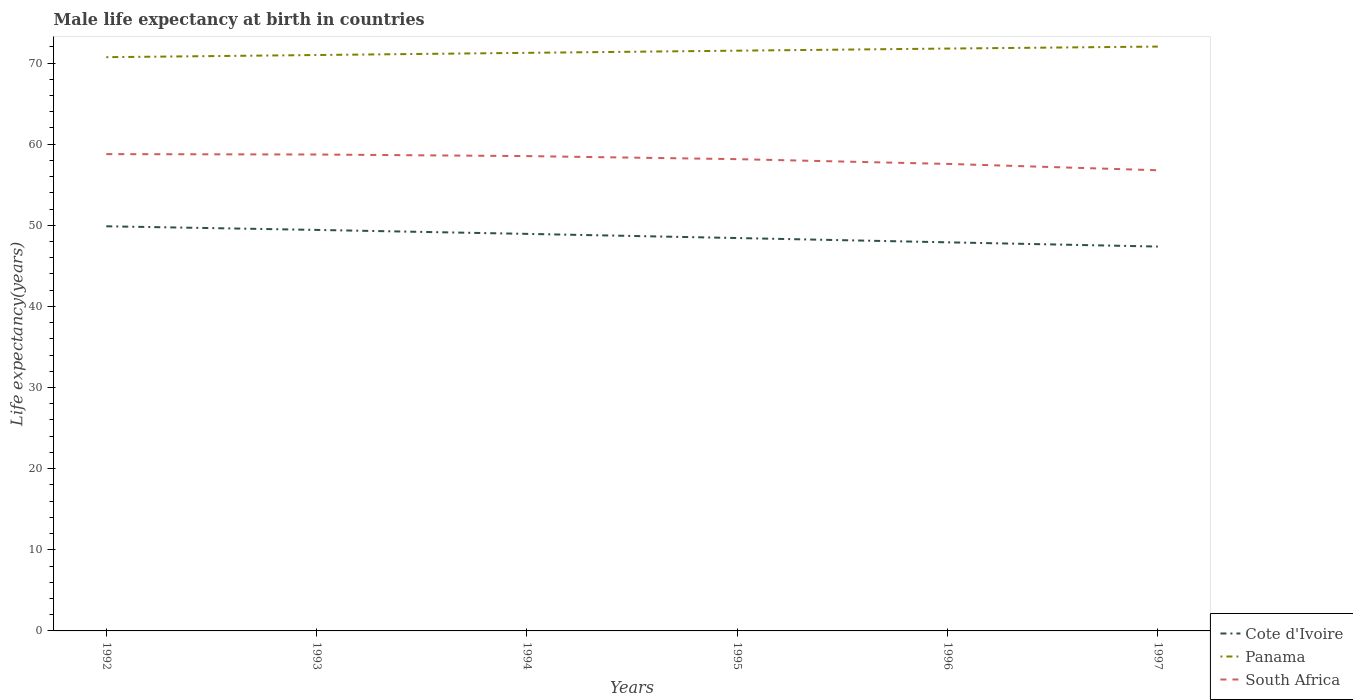Does the line corresponding to South Africa intersect with the line corresponding to Cote d'Ivoire?
Make the answer very short. No. Is the number of lines equal to the number of legend labels?
Keep it short and to the point. Yes. Across all years, what is the maximum male life expectancy at birth in Cote d'Ivoire?
Provide a succinct answer. 47.38. In which year was the male life expectancy at birth in Panama maximum?
Your answer should be very brief. 1992. What is the total male life expectancy at birth in Panama in the graph?
Provide a short and direct response. -0.25. What is the difference between the highest and the second highest male life expectancy at birth in Panama?
Your answer should be very brief. 1.31. What is the difference between the highest and the lowest male life expectancy at birth in Cote d'Ivoire?
Offer a very short reply. 3. How many lines are there?
Your answer should be compact. 3. Does the graph contain any zero values?
Provide a succinct answer. No. How many legend labels are there?
Provide a short and direct response. 3. What is the title of the graph?
Offer a very short reply. Male life expectancy at birth in countries. What is the label or title of the X-axis?
Provide a short and direct response. Years. What is the label or title of the Y-axis?
Offer a very short reply. Life expectancy(years). What is the Life expectancy(years) of Cote d'Ivoire in 1992?
Make the answer very short. 49.88. What is the Life expectancy(years) of Panama in 1992?
Make the answer very short. 70.72. What is the Life expectancy(years) of South Africa in 1992?
Your answer should be compact. 58.77. What is the Life expectancy(years) in Cote d'Ivoire in 1993?
Provide a succinct answer. 49.43. What is the Life expectancy(years) of Panama in 1993?
Make the answer very short. 70.99. What is the Life expectancy(years) of South Africa in 1993?
Provide a short and direct response. 58.72. What is the Life expectancy(years) in Cote d'Ivoire in 1994?
Provide a short and direct response. 48.94. What is the Life expectancy(years) of Panama in 1994?
Your answer should be very brief. 71.25. What is the Life expectancy(years) in South Africa in 1994?
Provide a short and direct response. 58.53. What is the Life expectancy(years) of Cote d'Ivoire in 1995?
Keep it short and to the point. 48.43. What is the Life expectancy(years) of Panama in 1995?
Your answer should be very brief. 71.52. What is the Life expectancy(years) in South Africa in 1995?
Provide a short and direct response. 58.15. What is the Life expectancy(years) in Cote d'Ivoire in 1996?
Your answer should be compact. 47.9. What is the Life expectancy(years) of Panama in 1996?
Your answer should be compact. 71.78. What is the Life expectancy(years) of South Africa in 1996?
Keep it short and to the point. 57.56. What is the Life expectancy(years) in Cote d'Ivoire in 1997?
Provide a succinct answer. 47.38. What is the Life expectancy(years) of Panama in 1997?
Provide a succinct answer. 72.03. What is the Life expectancy(years) of South Africa in 1997?
Your answer should be very brief. 56.78. Across all years, what is the maximum Life expectancy(years) of Cote d'Ivoire?
Offer a very short reply. 49.88. Across all years, what is the maximum Life expectancy(years) in Panama?
Offer a terse response. 72.03. Across all years, what is the maximum Life expectancy(years) in South Africa?
Give a very brief answer. 58.77. Across all years, what is the minimum Life expectancy(years) in Cote d'Ivoire?
Make the answer very short. 47.38. Across all years, what is the minimum Life expectancy(years) of Panama?
Offer a very short reply. 70.72. Across all years, what is the minimum Life expectancy(years) of South Africa?
Your response must be concise. 56.78. What is the total Life expectancy(years) of Cote d'Ivoire in the graph?
Keep it short and to the point. 291.95. What is the total Life expectancy(years) of Panama in the graph?
Your answer should be compact. 428.29. What is the total Life expectancy(years) of South Africa in the graph?
Your answer should be compact. 348.52. What is the difference between the Life expectancy(years) in Cote d'Ivoire in 1992 and that in 1993?
Offer a very short reply. 0.45. What is the difference between the Life expectancy(years) in Panama in 1992 and that in 1993?
Keep it short and to the point. -0.27. What is the difference between the Life expectancy(years) of South Africa in 1992 and that in 1993?
Offer a terse response. 0.05. What is the difference between the Life expectancy(years) of Cote d'Ivoire in 1992 and that in 1994?
Ensure brevity in your answer.  0.94. What is the difference between the Life expectancy(years) in Panama in 1992 and that in 1994?
Give a very brief answer. -0.54. What is the difference between the Life expectancy(years) in South Africa in 1992 and that in 1994?
Provide a succinct answer. 0.24. What is the difference between the Life expectancy(years) in Cote d'Ivoire in 1992 and that in 1995?
Your answer should be compact. 1.45. What is the difference between the Life expectancy(years) in Panama in 1992 and that in 1995?
Provide a succinct answer. -0.8. What is the difference between the Life expectancy(years) of South Africa in 1992 and that in 1995?
Keep it short and to the point. 0.62. What is the difference between the Life expectancy(years) in Cote d'Ivoire in 1992 and that in 1996?
Provide a succinct answer. 1.98. What is the difference between the Life expectancy(years) in Panama in 1992 and that in 1996?
Provide a short and direct response. -1.06. What is the difference between the Life expectancy(years) in South Africa in 1992 and that in 1996?
Keep it short and to the point. 1.21. What is the difference between the Life expectancy(years) in Cote d'Ivoire in 1992 and that in 1997?
Provide a succinct answer. 2.5. What is the difference between the Life expectancy(years) in Panama in 1992 and that in 1997?
Your answer should be very brief. -1.31. What is the difference between the Life expectancy(years) of South Africa in 1992 and that in 1997?
Provide a succinct answer. 1.99. What is the difference between the Life expectancy(years) in Cote d'Ivoire in 1993 and that in 1994?
Your answer should be compact. 0.49. What is the difference between the Life expectancy(years) of Panama in 1993 and that in 1994?
Make the answer very short. -0.27. What is the difference between the Life expectancy(years) of South Africa in 1993 and that in 1994?
Your answer should be very brief. 0.2. What is the difference between the Life expectancy(years) in Panama in 1993 and that in 1995?
Your answer should be very brief. -0.54. What is the difference between the Life expectancy(years) in South Africa in 1993 and that in 1995?
Offer a terse response. 0.57. What is the difference between the Life expectancy(years) in Cote d'Ivoire in 1993 and that in 1996?
Your response must be concise. 1.53. What is the difference between the Life expectancy(years) of Panama in 1993 and that in 1996?
Your answer should be compact. -0.8. What is the difference between the Life expectancy(years) in South Africa in 1993 and that in 1996?
Your answer should be compact. 1.16. What is the difference between the Life expectancy(years) in Cote d'Ivoire in 1993 and that in 1997?
Keep it short and to the point. 2.05. What is the difference between the Life expectancy(years) in Panama in 1993 and that in 1997?
Make the answer very short. -1.04. What is the difference between the Life expectancy(years) in South Africa in 1993 and that in 1997?
Provide a short and direct response. 1.94. What is the difference between the Life expectancy(years) in Cote d'Ivoire in 1994 and that in 1995?
Make the answer very short. 0.51. What is the difference between the Life expectancy(years) of Panama in 1994 and that in 1995?
Provide a succinct answer. -0.27. What is the difference between the Life expectancy(years) in South Africa in 1994 and that in 1995?
Offer a terse response. 0.38. What is the difference between the Life expectancy(years) of Cote d'Ivoire in 1994 and that in 1996?
Give a very brief answer. 1.04. What is the difference between the Life expectancy(years) of Panama in 1994 and that in 1996?
Your response must be concise. -0.53. What is the difference between the Life expectancy(years) in South Africa in 1994 and that in 1996?
Keep it short and to the point. 0.96. What is the difference between the Life expectancy(years) of Cote d'Ivoire in 1994 and that in 1997?
Keep it short and to the point. 1.56. What is the difference between the Life expectancy(years) in Panama in 1994 and that in 1997?
Ensure brevity in your answer.  -0.77. What is the difference between the Life expectancy(years) in South Africa in 1994 and that in 1997?
Your response must be concise. 1.75. What is the difference between the Life expectancy(years) in Cote d'Ivoire in 1995 and that in 1996?
Ensure brevity in your answer.  0.53. What is the difference between the Life expectancy(years) of Panama in 1995 and that in 1996?
Your answer should be compact. -0.26. What is the difference between the Life expectancy(years) of South Africa in 1995 and that in 1996?
Make the answer very short. 0.59. What is the difference between the Life expectancy(years) of Panama in 1995 and that in 1997?
Give a very brief answer. -0.51. What is the difference between the Life expectancy(years) in South Africa in 1995 and that in 1997?
Ensure brevity in your answer.  1.37. What is the difference between the Life expectancy(years) of Cote d'Ivoire in 1996 and that in 1997?
Keep it short and to the point. 0.52. What is the difference between the Life expectancy(years) of Panama in 1996 and that in 1997?
Your answer should be very brief. -0.24. What is the difference between the Life expectancy(years) in South Africa in 1996 and that in 1997?
Provide a succinct answer. 0.78. What is the difference between the Life expectancy(years) in Cote d'Ivoire in 1992 and the Life expectancy(years) in Panama in 1993?
Keep it short and to the point. -21.11. What is the difference between the Life expectancy(years) in Cote d'Ivoire in 1992 and the Life expectancy(years) in South Africa in 1993?
Your answer should be very brief. -8.85. What is the difference between the Life expectancy(years) of Panama in 1992 and the Life expectancy(years) of South Africa in 1993?
Provide a succinct answer. 12. What is the difference between the Life expectancy(years) of Cote d'Ivoire in 1992 and the Life expectancy(years) of Panama in 1994?
Offer a terse response. -21.38. What is the difference between the Life expectancy(years) in Cote d'Ivoire in 1992 and the Life expectancy(years) in South Africa in 1994?
Make the answer very short. -8.65. What is the difference between the Life expectancy(years) of Panama in 1992 and the Life expectancy(years) of South Africa in 1994?
Offer a very short reply. 12.19. What is the difference between the Life expectancy(years) of Cote d'Ivoire in 1992 and the Life expectancy(years) of Panama in 1995?
Give a very brief answer. -21.65. What is the difference between the Life expectancy(years) in Cote d'Ivoire in 1992 and the Life expectancy(years) in South Africa in 1995?
Offer a terse response. -8.28. What is the difference between the Life expectancy(years) in Panama in 1992 and the Life expectancy(years) in South Africa in 1995?
Make the answer very short. 12.57. What is the difference between the Life expectancy(years) of Cote d'Ivoire in 1992 and the Life expectancy(years) of Panama in 1996?
Offer a terse response. -21.91. What is the difference between the Life expectancy(years) in Cote d'Ivoire in 1992 and the Life expectancy(years) in South Africa in 1996?
Offer a very short reply. -7.69. What is the difference between the Life expectancy(years) in Panama in 1992 and the Life expectancy(years) in South Africa in 1996?
Your answer should be very brief. 13.16. What is the difference between the Life expectancy(years) in Cote d'Ivoire in 1992 and the Life expectancy(years) in Panama in 1997?
Your answer should be very brief. -22.15. What is the difference between the Life expectancy(years) of Cote d'Ivoire in 1992 and the Life expectancy(years) of South Africa in 1997?
Offer a terse response. -6.91. What is the difference between the Life expectancy(years) in Panama in 1992 and the Life expectancy(years) in South Africa in 1997?
Provide a short and direct response. 13.94. What is the difference between the Life expectancy(years) of Cote d'Ivoire in 1993 and the Life expectancy(years) of Panama in 1994?
Keep it short and to the point. -21.83. What is the difference between the Life expectancy(years) in Cote d'Ivoire in 1993 and the Life expectancy(years) in South Africa in 1994?
Keep it short and to the point. -9.1. What is the difference between the Life expectancy(years) of Panama in 1993 and the Life expectancy(years) of South Africa in 1994?
Your response must be concise. 12.46. What is the difference between the Life expectancy(years) of Cote d'Ivoire in 1993 and the Life expectancy(years) of Panama in 1995?
Your response must be concise. -22.09. What is the difference between the Life expectancy(years) in Cote d'Ivoire in 1993 and the Life expectancy(years) in South Africa in 1995?
Your response must be concise. -8.72. What is the difference between the Life expectancy(years) of Panama in 1993 and the Life expectancy(years) of South Africa in 1995?
Your answer should be very brief. 12.84. What is the difference between the Life expectancy(years) in Cote d'Ivoire in 1993 and the Life expectancy(years) in Panama in 1996?
Make the answer very short. -22.35. What is the difference between the Life expectancy(years) in Cote d'Ivoire in 1993 and the Life expectancy(years) in South Africa in 1996?
Provide a short and direct response. -8.14. What is the difference between the Life expectancy(years) of Panama in 1993 and the Life expectancy(years) of South Africa in 1996?
Ensure brevity in your answer.  13.42. What is the difference between the Life expectancy(years) in Cote d'Ivoire in 1993 and the Life expectancy(years) in Panama in 1997?
Your response must be concise. -22.6. What is the difference between the Life expectancy(years) of Cote d'Ivoire in 1993 and the Life expectancy(years) of South Africa in 1997?
Your answer should be very brief. -7.35. What is the difference between the Life expectancy(years) of Panama in 1993 and the Life expectancy(years) of South Africa in 1997?
Give a very brief answer. 14.21. What is the difference between the Life expectancy(years) of Cote d'Ivoire in 1994 and the Life expectancy(years) of Panama in 1995?
Keep it short and to the point. -22.58. What is the difference between the Life expectancy(years) of Cote d'Ivoire in 1994 and the Life expectancy(years) of South Africa in 1995?
Offer a very short reply. -9.21. What is the difference between the Life expectancy(years) in Panama in 1994 and the Life expectancy(years) in South Africa in 1995?
Offer a very short reply. 13.1. What is the difference between the Life expectancy(years) in Cote d'Ivoire in 1994 and the Life expectancy(years) in Panama in 1996?
Your answer should be compact. -22.84. What is the difference between the Life expectancy(years) in Cote d'Ivoire in 1994 and the Life expectancy(years) in South Africa in 1996?
Make the answer very short. -8.62. What is the difference between the Life expectancy(years) of Panama in 1994 and the Life expectancy(years) of South Africa in 1996?
Offer a terse response. 13.69. What is the difference between the Life expectancy(years) of Cote d'Ivoire in 1994 and the Life expectancy(years) of Panama in 1997?
Your answer should be very brief. -23.09. What is the difference between the Life expectancy(years) of Cote d'Ivoire in 1994 and the Life expectancy(years) of South Africa in 1997?
Provide a succinct answer. -7.84. What is the difference between the Life expectancy(years) in Panama in 1994 and the Life expectancy(years) in South Africa in 1997?
Offer a terse response. 14.47. What is the difference between the Life expectancy(years) in Cote d'Ivoire in 1995 and the Life expectancy(years) in Panama in 1996?
Ensure brevity in your answer.  -23.36. What is the difference between the Life expectancy(years) in Cote d'Ivoire in 1995 and the Life expectancy(years) in South Africa in 1996?
Make the answer very short. -9.14. What is the difference between the Life expectancy(years) in Panama in 1995 and the Life expectancy(years) in South Africa in 1996?
Make the answer very short. 13.96. What is the difference between the Life expectancy(years) of Cote d'Ivoire in 1995 and the Life expectancy(years) of Panama in 1997?
Your answer should be compact. -23.6. What is the difference between the Life expectancy(years) in Cote d'Ivoire in 1995 and the Life expectancy(years) in South Africa in 1997?
Your answer should be compact. -8.35. What is the difference between the Life expectancy(years) in Panama in 1995 and the Life expectancy(years) in South Africa in 1997?
Keep it short and to the point. 14.74. What is the difference between the Life expectancy(years) of Cote d'Ivoire in 1996 and the Life expectancy(years) of Panama in 1997?
Your response must be concise. -24.13. What is the difference between the Life expectancy(years) in Cote d'Ivoire in 1996 and the Life expectancy(years) in South Africa in 1997?
Your answer should be compact. -8.88. What is the difference between the Life expectancy(years) in Panama in 1996 and the Life expectancy(years) in South Africa in 1997?
Give a very brief answer. 15. What is the average Life expectancy(years) of Cote d'Ivoire per year?
Offer a very short reply. 48.66. What is the average Life expectancy(years) in Panama per year?
Provide a short and direct response. 71.38. What is the average Life expectancy(years) in South Africa per year?
Give a very brief answer. 58.09. In the year 1992, what is the difference between the Life expectancy(years) of Cote d'Ivoire and Life expectancy(years) of Panama?
Keep it short and to the point. -20.84. In the year 1992, what is the difference between the Life expectancy(years) of Cote d'Ivoire and Life expectancy(years) of South Africa?
Offer a very short reply. -8.9. In the year 1992, what is the difference between the Life expectancy(years) in Panama and Life expectancy(years) in South Africa?
Give a very brief answer. 11.95. In the year 1993, what is the difference between the Life expectancy(years) of Cote d'Ivoire and Life expectancy(years) of Panama?
Your answer should be very brief. -21.56. In the year 1993, what is the difference between the Life expectancy(years) in Cote d'Ivoire and Life expectancy(years) in South Africa?
Give a very brief answer. -9.29. In the year 1993, what is the difference between the Life expectancy(years) of Panama and Life expectancy(years) of South Africa?
Offer a terse response. 12.26. In the year 1994, what is the difference between the Life expectancy(years) of Cote d'Ivoire and Life expectancy(years) of Panama?
Provide a succinct answer. -22.32. In the year 1994, what is the difference between the Life expectancy(years) of Cote d'Ivoire and Life expectancy(years) of South Africa?
Offer a very short reply. -9.59. In the year 1994, what is the difference between the Life expectancy(years) of Panama and Life expectancy(years) of South Africa?
Offer a very short reply. 12.73. In the year 1995, what is the difference between the Life expectancy(years) in Cote d'Ivoire and Life expectancy(years) in Panama?
Offer a terse response. -23.09. In the year 1995, what is the difference between the Life expectancy(years) in Cote d'Ivoire and Life expectancy(years) in South Africa?
Your answer should be compact. -9.72. In the year 1995, what is the difference between the Life expectancy(years) in Panama and Life expectancy(years) in South Africa?
Your response must be concise. 13.37. In the year 1996, what is the difference between the Life expectancy(years) in Cote d'Ivoire and Life expectancy(years) in Panama?
Offer a terse response. -23.88. In the year 1996, what is the difference between the Life expectancy(years) of Cote d'Ivoire and Life expectancy(years) of South Africa?
Offer a very short reply. -9.66. In the year 1996, what is the difference between the Life expectancy(years) of Panama and Life expectancy(years) of South Africa?
Keep it short and to the point. 14.22. In the year 1997, what is the difference between the Life expectancy(years) in Cote d'Ivoire and Life expectancy(years) in Panama?
Your response must be concise. -24.65. In the year 1997, what is the difference between the Life expectancy(years) in Cote d'Ivoire and Life expectancy(years) in South Africa?
Make the answer very short. -9.4. In the year 1997, what is the difference between the Life expectancy(years) in Panama and Life expectancy(years) in South Africa?
Ensure brevity in your answer.  15.25. What is the ratio of the Life expectancy(years) of Cote d'Ivoire in 1992 to that in 1993?
Offer a terse response. 1.01. What is the ratio of the Life expectancy(years) in Cote d'Ivoire in 1992 to that in 1994?
Offer a terse response. 1.02. What is the ratio of the Life expectancy(years) of South Africa in 1992 to that in 1994?
Keep it short and to the point. 1. What is the ratio of the Life expectancy(years) of Cote d'Ivoire in 1992 to that in 1995?
Make the answer very short. 1.03. What is the ratio of the Life expectancy(years) in Panama in 1992 to that in 1995?
Your answer should be very brief. 0.99. What is the ratio of the Life expectancy(years) in South Africa in 1992 to that in 1995?
Your answer should be very brief. 1.01. What is the ratio of the Life expectancy(years) of Cote d'Ivoire in 1992 to that in 1996?
Ensure brevity in your answer.  1.04. What is the ratio of the Life expectancy(years) of Panama in 1992 to that in 1996?
Provide a short and direct response. 0.99. What is the ratio of the Life expectancy(years) in South Africa in 1992 to that in 1996?
Offer a terse response. 1.02. What is the ratio of the Life expectancy(years) of Cote d'Ivoire in 1992 to that in 1997?
Your answer should be very brief. 1.05. What is the ratio of the Life expectancy(years) in Panama in 1992 to that in 1997?
Provide a short and direct response. 0.98. What is the ratio of the Life expectancy(years) in South Africa in 1992 to that in 1997?
Your answer should be very brief. 1.04. What is the ratio of the Life expectancy(years) of Panama in 1993 to that in 1994?
Provide a succinct answer. 1. What is the ratio of the Life expectancy(years) of Cote d'Ivoire in 1993 to that in 1995?
Give a very brief answer. 1.02. What is the ratio of the Life expectancy(years) in Panama in 1993 to that in 1995?
Your answer should be very brief. 0.99. What is the ratio of the Life expectancy(years) in South Africa in 1993 to that in 1995?
Offer a very short reply. 1.01. What is the ratio of the Life expectancy(years) of Cote d'Ivoire in 1993 to that in 1996?
Keep it short and to the point. 1.03. What is the ratio of the Life expectancy(years) of Panama in 1993 to that in 1996?
Make the answer very short. 0.99. What is the ratio of the Life expectancy(years) of South Africa in 1993 to that in 1996?
Ensure brevity in your answer.  1.02. What is the ratio of the Life expectancy(years) of Cote d'Ivoire in 1993 to that in 1997?
Your answer should be very brief. 1.04. What is the ratio of the Life expectancy(years) in Panama in 1993 to that in 1997?
Offer a terse response. 0.99. What is the ratio of the Life expectancy(years) in South Africa in 1993 to that in 1997?
Your answer should be compact. 1.03. What is the ratio of the Life expectancy(years) of Cote d'Ivoire in 1994 to that in 1995?
Offer a very short reply. 1.01. What is the ratio of the Life expectancy(years) of South Africa in 1994 to that in 1995?
Provide a short and direct response. 1.01. What is the ratio of the Life expectancy(years) in Cote d'Ivoire in 1994 to that in 1996?
Ensure brevity in your answer.  1.02. What is the ratio of the Life expectancy(years) of South Africa in 1994 to that in 1996?
Ensure brevity in your answer.  1.02. What is the ratio of the Life expectancy(years) of Cote d'Ivoire in 1994 to that in 1997?
Give a very brief answer. 1.03. What is the ratio of the Life expectancy(years) of Panama in 1994 to that in 1997?
Offer a terse response. 0.99. What is the ratio of the Life expectancy(years) of South Africa in 1994 to that in 1997?
Your answer should be compact. 1.03. What is the ratio of the Life expectancy(years) of Panama in 1995 to that in 1996?
Provide a succinct answer. 1. What is the ratio of the Life expectancy(years) of South Africa in 1995 to that in 1996?
Keep it short and to the point. 1.01. What is the ratio of the Life expectancy(years) of Cote d'Ivoire in 1995 to that in 1997?
Provide a succinct answer. 1.02. What is the ratio of the Life expectancy(years) in Panama in 1995 to that in 1997?
Give a very brief answer. 0.99. What is the ratio of the Life expectancy(years) in South Africa in 1995 to that in 1997?
Give a very brief answer. 1.02. What is the ratio of the Life expectancy(years) of Panama in 1996 to that in 1997?
Provide a short and direct response. 1. What is the ratio of the Life expectancy(years) of South Africa in 1996 to that in 1997?
Provide a short and direct response. 1.01. What is the difference between the highest and the second highest Life expectancy(years) in Cote d'Ivoire?
Keep it short and to the point. 0.45. What is the difference between the highest and the second highest Life expectancy(years) in Panama?
Your answer should be compact. 0.24. What is the difference between the highest and the second highest Life expectancy(years) of South Africa?
Offer a very short reply. 0.05. What is the difference between the highest and the lowest Life expectancy(years) of Cote d'Ivoire?
Provide a short and direct response. 2.5. What is the difference between the highest and the lowest Life expectancy(years) in Panama?
Offer a very short reply. 1.31. What is the difference between the highest and the lowest Life expectancy(years) in South Africa?
Ensure brevity in your answer.  1.99. 